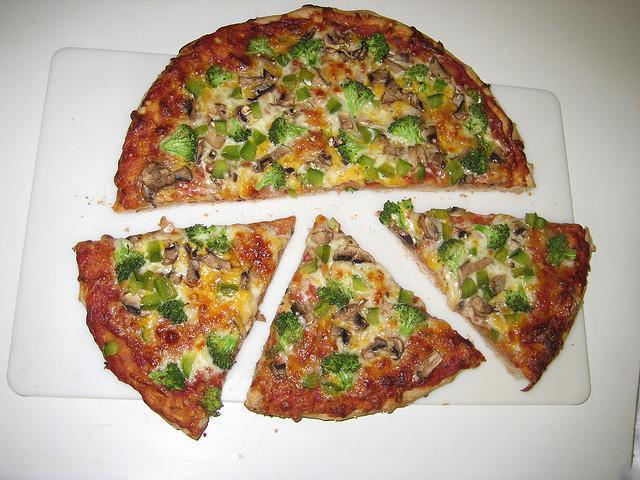How many slices of pizza are there?
Give a very brief answer. 4. How many pizzas can you see?
Give a very brief answer. 4. How many people are in the picture?
Give a very brief answer. 0. 